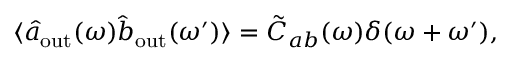Convert formula to latex. <formula><loc_0><loc_0><loc_500><loc_500>\langle \hat { a } _ { o u t } ( \omega ) \hat { b } _ { o u t } ( \omega ^ { \prime } ) \rangle = \tilde { C } _ { a b } ( \omega ) \delta ( \omega + \omega ^ { \prime } ) ,</formula> 